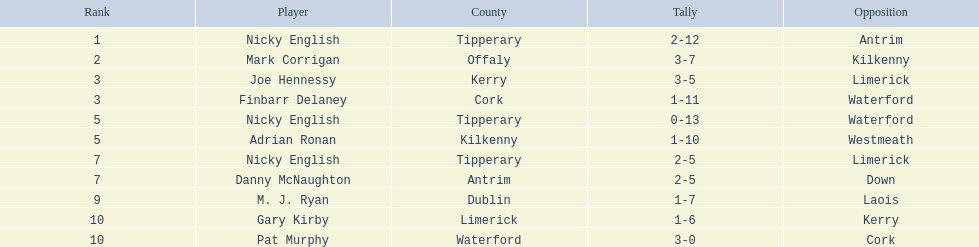Which of the following players were ranked in the bottom 5? Nicky English, Danny McNaughton, M. J. Ryan, Gary Kirby, Pat Murphy. Of these, whose tallies were not 2-5? M. J. Ryan, Gary Kirby, Pat Murphy. From the above three, which one scored more than 9 total points? M. J. Ryan. 